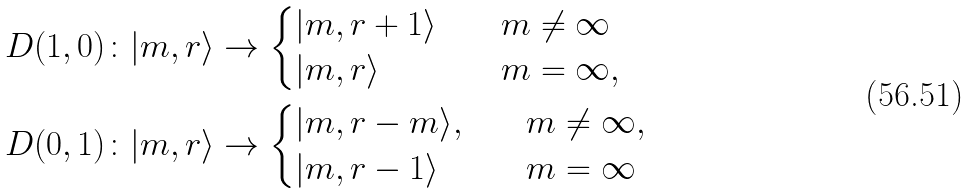Convert formula to latex. <formula><loc_0><loc_0><loc_500><loc_500>D ( 1 , 0 ) \colon | m , r \rangle & \to \begin{cases} | m , r + 1 \rangle \quad & m \neq \infty \\ | m , r \rangle \quad & m = \infty , \end{cases} \\ D ( 0 , 1 ) \colon | m , r \rangle & \to \begin{cases} | m , r - m \rangle , \quad & m \neq \infty , \\ | m , r - 1 \rangle \quad & m = \infty \end{cases}</formula> 